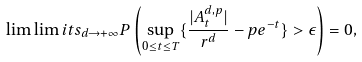<formula> <loc_0><loc_0><loc_500><loc_500>\lim \lim i t s _ { d \rightarrow + \infty } P \left ( \sup _ { 0 \leq t \leq T } \{ \frac { | A _ { t } ^ { d , p } | } { r ^ { d } } - p e ^ { - t } \} > \epsilon \right ) = 0 ,</formula> 